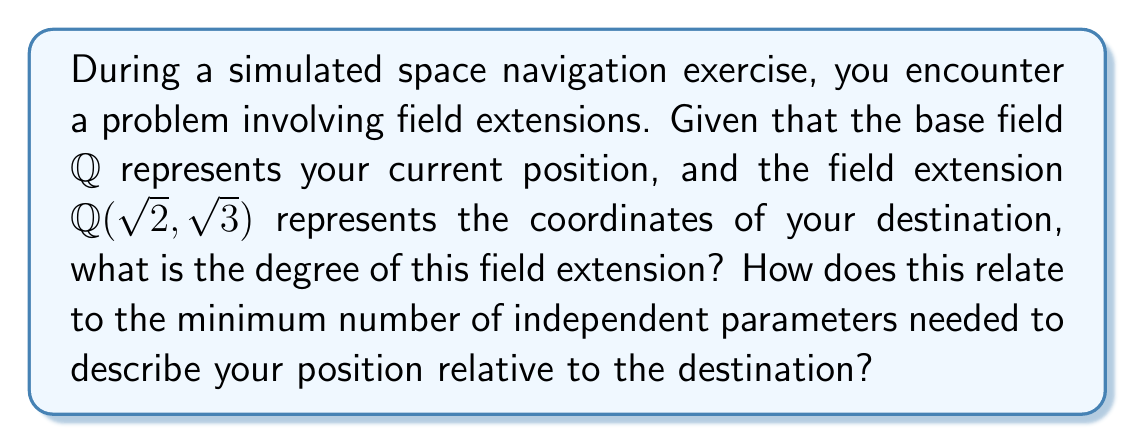What is the answer to this math problem? Let's approach this step-by-step:

1) First, we need to understand what $\mathbb{Q}(\sqrt{2}, \sqrt{3})$ means. This is the smallest field containing $\mathbb{Q}$, $\sqrt{2}$, and $\sqrt{3}$.

2) To find the degree of this extension, we need to consider the tower of extensions:

   $\mathbb{Q} \subset \mathbb{Q}(\sqrt{2}) \subset \mathbb{Q}(\sqrt{2}, \sqrt{3})$

3) Let's consider each step:
   
   a) $[\mathbb{Q}(\sqrt{2}) : \mathbb{Q}] = 2$ because $\sqrt{2}$ is not in $\mathbb{Q}$ and $X^2 - 2$ is its minimal polynomial over $\mathbb{Q}$.
   
   b) Now, we need to determine $[\mathbb{Q}(\sqrt{2}, \sqrt{3}) : \mathbb{Q}(\sqrt{2})]$. 
      If $\sqrt{3} \in \mathbb{Q}(\sqrt{2})$, this would be 1. Otherwise, it's 2.

4) We can prove that $\sqrt{3} \notin \mathbb{Q}(\sqrt{2})$:
   If $\sqrt{3} = a + b\sqrt{2}$ for some $a,b \in \mathbb{Q}$, then
   $3 = (a + b\sqrt{2})^2 = a^2 + 2b^2 + 2ab\sqrt{2}$
   This is impossible because $\sqrt{2}$ is irrational.

5) Therefore, $[\mathbb{Q}(\sqrt{2}, \sqrt{3}) : \mathbb{Q}(\sqrt{2})] = 2$

6) By the multiplicativity of degrees in towers:
   $[\mathbb{Q}(\sqrt{2}, \sqrt{3}) : \mathbb{Q}] = [\mathbb{Q}(\sqrt{2}, \sqrt{3}) : \mathbb{Q}(\sqrt{2})] \cdot [\mathbb{Q}(\sqrt{2}) : \mathbb{Q}] = 2 \cdot 2 = 4$

7) In terms of navigation, this means you need 4 independent parameters to describe your position relative to the destination. This could correspond to 3 spatial coordinates and 1 time coordinate in a space-time framework.
Answer: 4 